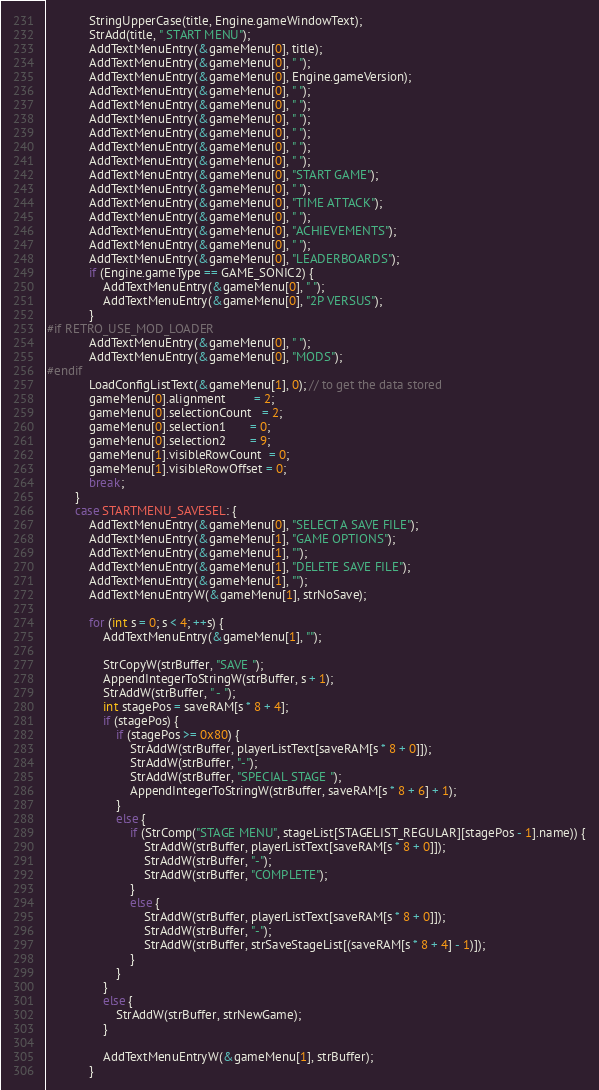<code> <loc_0><loc_0><loc_500><loc_500><_C++_>            StringUpperCase(title, Engine.gameWindowText);
            StrAdd(title, " START MENU");
            AddTextMenuEntry(&gameMenu[0], title);
            AddTextMenuEntry(&gameMenu[0], " ");
            AddTextMenuEntry(&gameMenu[0], Engine.gameVersion);
            AddTextMenuEntry(&gameMenu[0], " ");
            AddTextMenuEntry(&gameMenu[0], " ");
            AddTextMenuEntry(&gameMenu[0], " ");
            AddTextMenuEntry(&gameMenu[0], " ");
            AddTextMenuEntry(&gameMenu[0], " ");
            AddTextMenuEntry(&gameMenu[0], " ");
            AddTextMenuEntry(&gameMenu[0], "START GAME");
            AddTextMenuEntry(&gameMenu[0], " ");
            AddTextMenuEntry(&gameMenu[0], "TIME ATTACK");
            AddTextMenuEntry(&gameMenu[0], " ");
            AddTextMenuEntry(&gameMenu[0], "ACHIEVEMENTS");
            AddTextMenuEntry(&gameMenu[0], " ");
            AddTextMenuEntry(&gameMenu[0], "LEADERBOARDS");
            if (Engine.gameType == GAME_SONIC2) {
                AddTextMenuEntry(&gameMenu[0], " ");
                AddTextMenuEntry(&gameMenu[0], "2P VERSUS");
            }
#if RETRO_USE_MOD_LOADER
            AddTextMenuEntry(&gameMenu[0], " ");
            AddTextMenuEntry(&gameMenu[0], "MODS");
#endif
            LoadConfigListText(&gameMenu[1], 0); // to get the data stored
            gameMenu[0].alignment        = 2;
            gameMenu[0].selectionCount   = 2;
            gameMenu[0].selection1       = 0;
            gameMenu[0].selection2       = 9;
            gameMenu[1].visibleRowCount  = 0;
            gameMenu[1].visibleRowOffset = 0;
            break;
        }
        case STARTMENU_SAVESEL: {
            AddTextMenuEntry(&gameMenu[0], "SELECT A SAVE FILE");
            AddTextMenuEntry(&gameMenu[1], "GAME OPTIONS");
            AddTextMenuEntry(&gameMenu[1], "");
            AddTextMenuEntry(&gameMenu[1], "DELETE SAVE FILE");
            AddTextMenuEntry(&gameMenu[1], "");
            AddTextMenuEntryW(&gameMenu[1], strNoSave);

            for (int s = 0; s < 4; ++s) {
                AddTextMenuEntry(&gameMenu[1], "");

                StrCopyW(strBuffer, "SAVE ");
                AppendIntegerToStringW(strBuffer, s + 1);
                StrAddW(strBuffer, " - ");
                int stagePos = saveRAM[s * 8 + 4];
                if (stagePos) {
                    if (stagePos >= 0x80) {
                        StrAddW(strBuffer, playerListText[saveRAM[s * 8 + 0]]);
                        StrAddW(strBuffer, "-");
                        StrAddW(strBuffer, "SPECIAL STAGE ");
                        AppendIntegerToStringW(strBuffer, saveRAM[s * 8 + 6] + 1);
                    }
                    else {
                        if (StrComp("STAGE MENU", stageList[STAGELIST_REGULAR][stagePos - 1].name)) {
                            StrAddW(strBuffer, playerListText[saveRAM[s * 8 + 0]]);
                            StrAddW(strBuffer, "-");
                            StrAddW(strBuffer, "COMPLETE");
                        }
                        else {
                            StrAddW(strBuffer, playerListText[saveRAM[s * 8 + 0]]);
                            StrAddW(strBuffer, "-");
                            StrAddW(strBuffer, strSaveStageList[(saveRAM[s * 8 + 4] - 1)]);
                        }
                    }
                }
                else {
                    StrAddW(strBuffer, strNewGame);
                }

                AddTextMenuEntryW(&gameMenu[1], strBuffer);
            }</code> 